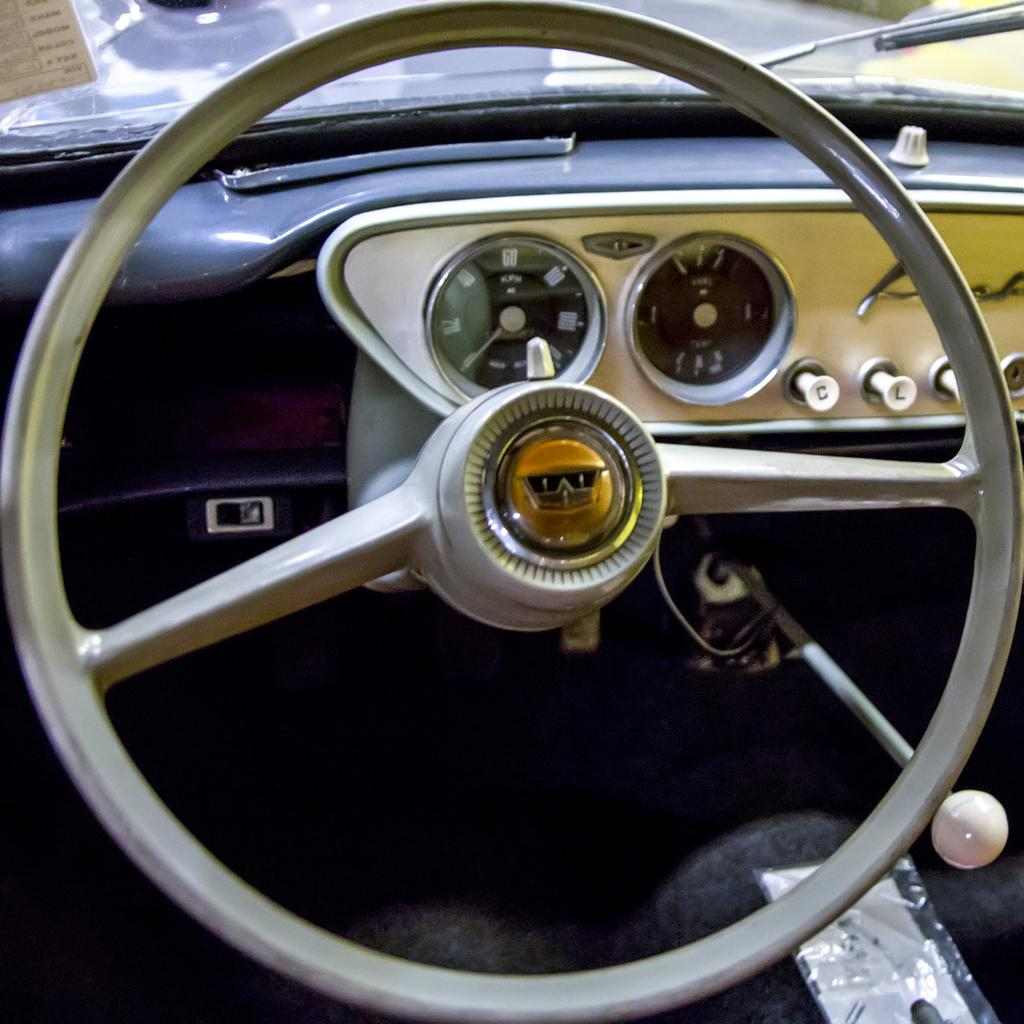What is the main object in the image? There is a steering wheel in the image. What instrument is used to measure speed in the image? There is a speedometer in the image. Can you describe any other elements in the image besides the steering wheel and speedometer? There are other unspecified elements in the image. Where is the bear playing with water in the image? There is no bear or water present in the image. 